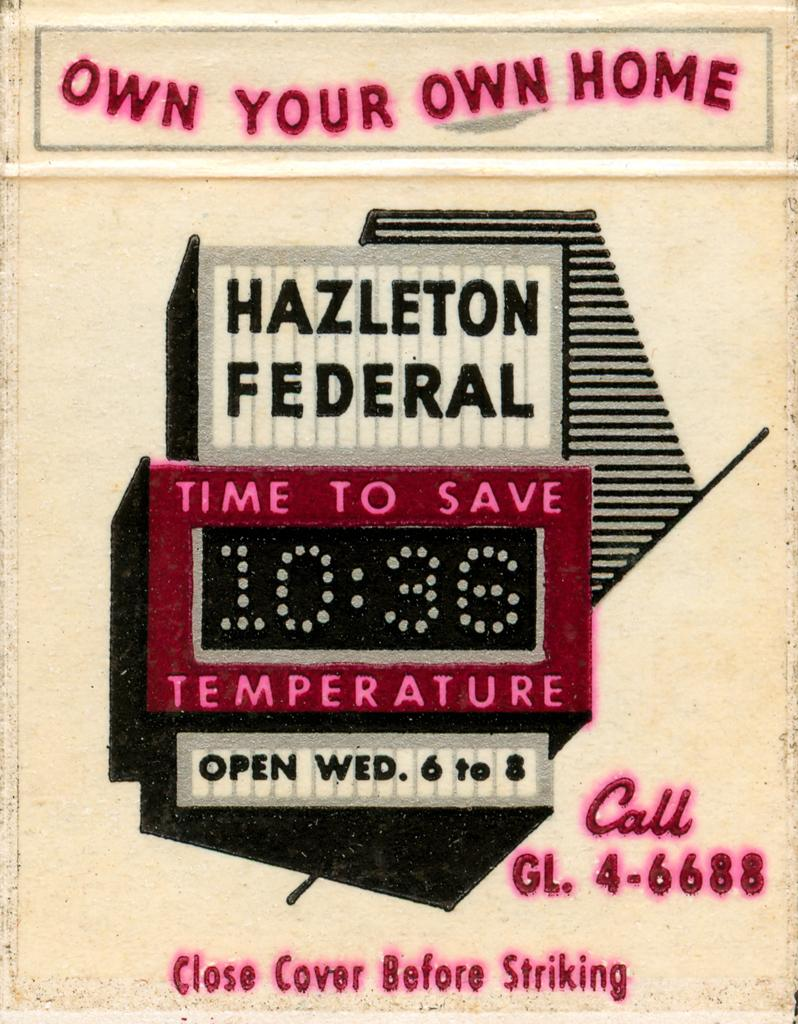<image>
Render a clear and concise summary of the photo. Poster telling you that you can own your own home. 